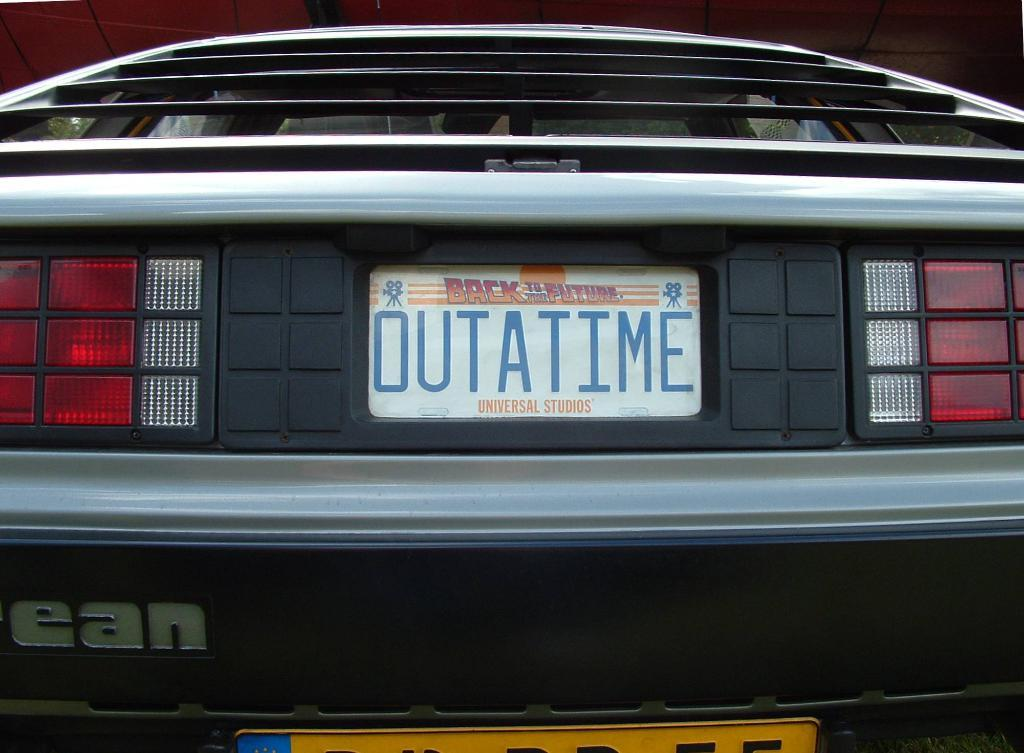What type of object is the main subject of the image? There is a vehicle in the image. How is the vehicle depicted in the image? The vehicle appears to be truncated. What else can be seen in the image besides the vehicle? There are lights, boards, and a whiteboard with text written on it in the image. How many icicles are hanging from the vehicle in the image? There are no icicles present in the image. What type of feast is being prepared on the whiteboard in the image? There is no feast being prepared on the whiteboard in the image; it contains text. 